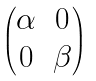Convert formula to latex. <formula><loc_0><loc_0><loc_500><loc_500>\begin{pmatrix} \alpha & 0 \\ 0 & \beta \end{pmatrix}</formula> 